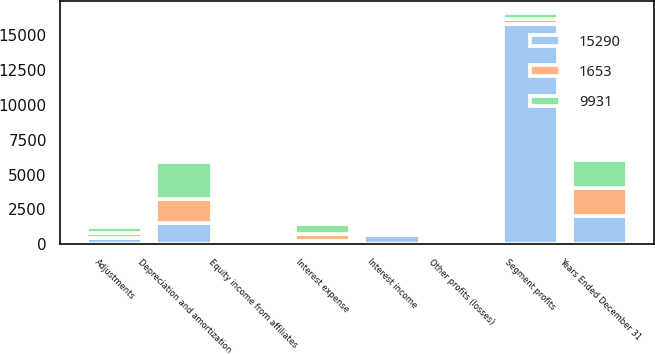Convert chart. <chart><loc_0><loc_0><loc_500><loc_500><stacked_bar_chart><ecel><fcel>Years Ended December 31<fcel>Segment profits<fcel>Other profits (losses)<fcel>Adjustments<fcel>Interest income<fcel>Interest expense<fcel>Equity income from affiliates<fcel>Depreciation and amortization<nl><fcel>9931<fcel>2010<fcel>413<fcel>87<fcel>401<fcel>83<fcel>715<fcel>175<fcel>2671<nl><fcel>1653<fcel>2009<fcel>413<fcel>137<fcel>399<fcel>210<fcel>460<fcel>153<fcel>1696<nl><fcel>15290<fcel>2008<fcel>15801<fcel>92<fcel>425<fcel>631<fcel>251<fcel>237<fcel>1530<nl></chart> 